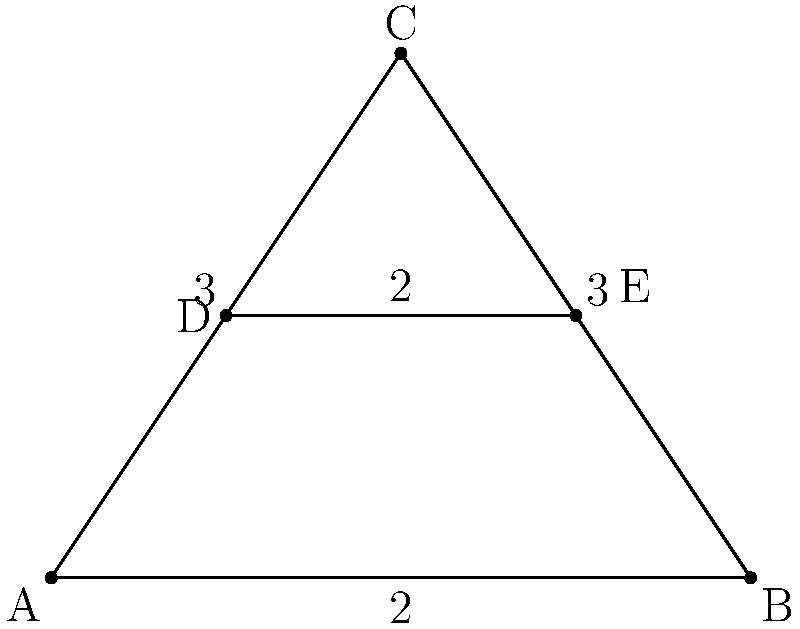In a cycling team's drafting formation, five cyclists are positioned at points A, B, C, D, and E as shown in the diagram. The lead cyclist is at point C, forming an equilateral triangle with cyclists at A and B. Cyclists at D and E form a line parallel to AB. If the distance between A and B is 4 meters, and the distance between D and E is 2 meters, what is the total area (in square meters) of the triangular region ADE? Let's approach this step-by-step:

1) First, we need to find the height of the equilateral triangle ABC.
   Let's call this height h.
   
   In an equilateral triangle, we can use the formula: $h = \frac{\sqrt{3}}{2} * side$
   
   The side length is 4, so: $h = \frac{\sqrt{3}}{2} * 4 = 2\sqrt{3}$

2) Now, we know that D and E are positioned halfway up this height.
   So, the height of triangle ADE is half of h: $\frac{h}{2} = \frac{2\sqrt{3}}{2} = \sqrt{3}$

3) The base of triangle ADE is the same as DE, which is given as 2 meters.

4) To find the area of a triangle, we use the formula: $Area = \frac{1}{2} * base * height$

5) Plugging in our values:
   $Area = \frac{1}{2} * 2 * \sqrt{3} = \sqrt{3}$

Therefore, the area of triangle ADE is $\sqrt{3}$ square meters.
Answer: $\sqrt{3}$ square meters 